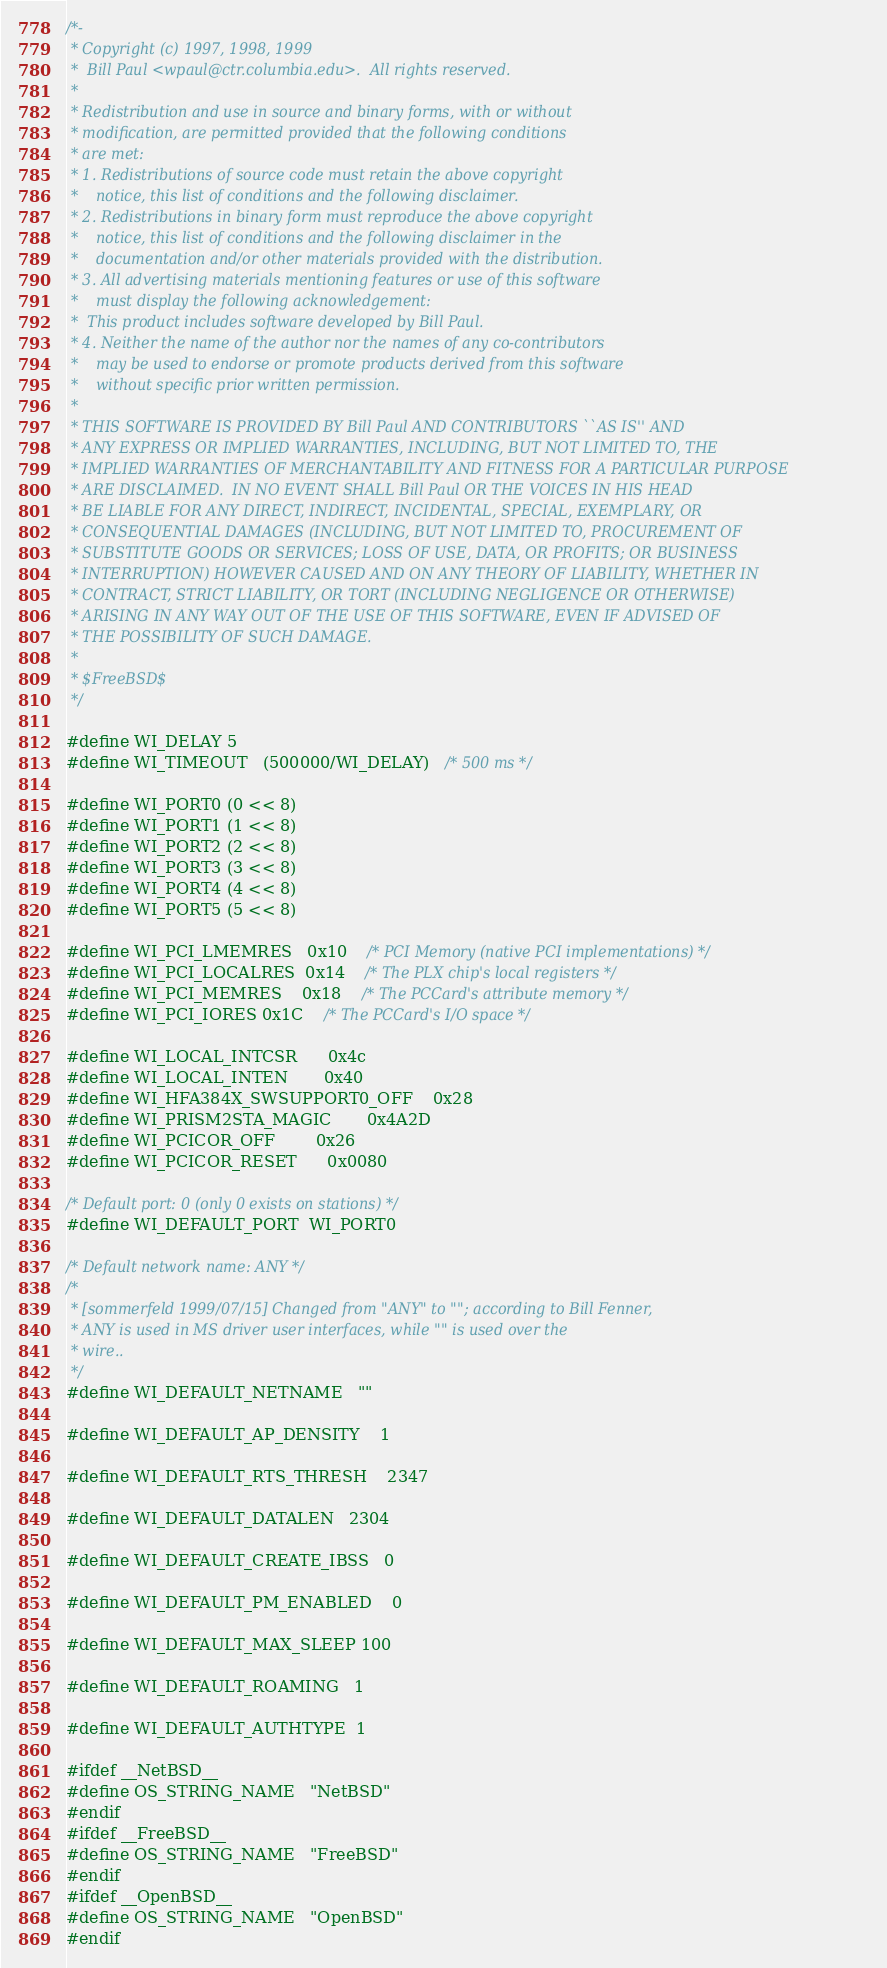Convert code to text. <code><loc_0><loc_0><loc_500><loc_500><_C_>/*-
 * Copyright (c) 1997, 1998, 1999
 *	Bill Paul <wpaul@ctr.columbia.edu>.  All rights reserved.
 *
 * Redistribution and use in source and binary forms, with or without
 * modification, are permitted provided that the following conditions
 * are met:
 * 1. Redistributions of source code must retain the above copyright
 *    notice, this list of conditions and the following disclaimer.
 * 2. Redistributions in binary form must reproduce the above copyright
 *    notice, this list of conditions and the following disclaimer in the
 *    documentation and/or other materials provided with the distribution.
 * 3. All advertising materials mentioning features or use of this software
 *    must display the following acknowledgement:
 *	This product includes software developed by Bill Paul.
 * 4. Neither the name of the author nor the names of any co-contributors
 *    may be used to endorse or promote products derived from this software
 *    without specific prior written permission.
 *
 * THIS SOFTWARE IS PROVIDED BY Bill Paul AND CONTRIBUTORS ``AS IS'' AND
 * ANY EXPRESS OR IMPLIED WARRANTIES, INCLUDING, BUT NOT LIMITED TO, THE
 * IMPLIED WARRANTIES OF MERCHANTABILITY AND FITNESS FOR A PARTICULAR PURPOSE
 * ARE DISCLAIMED.  IN NO EVENT SHALL Bill Paul OR THE VOICES IN HIS HEAD
 * BE LIABLE FOR ANY DIRECT, INDIRECT, INCIDENTAL, SPECIAL, EXEMPLARY, OR
 * CONSEQUENTIAL DAMAGES (INCLUDING, BUT NOT LIMITED TO, PROCUREMENT OF
 * SUBSTITUTE GOODS OR SERVICES; LOSS OF USE, DATA, OR PROFITS; OR BUSINESS
 * INTERRUPTION) HOWEVER CAUSED AND ON ANY THEORY OF LIABILITY, WHETHER IN
 * CONTRACT, STRICT LIABILITY, OR TORT (INCLUDING NEGLIGENCE OR OTHERWISE)
 * ARISING IN ANY WAY OUT OF THE USE OF THIS SOFTWARE, EVEN IF ADVISED OF
 * THE POSSIBILITY OF SUCH DAMAGE.
 *
 * $FreeBSD$
 */

#define WI_DELAY	5
#define WI_TIMEOUT	(500000/WI_DELAY)	/* 500 ms */

#define WI_PORT0	(0 << 8)
#define WI_PORT1	(1 << 8)
#define WI_PORT2	(2 << 8)
#define WI_PORT3	(3 << 8)
#define WI_PORT4	(4 << 8)
#define WI_PORT5	(5 << 8)

#define WI_PCI_LMEMRES	0x10	/* PCI Memory (native PCI implementations) */
#define WI_PCI_LOCALRES	0x14	/* The PLX chip's local registers */
#define WI_PCI_MEMRES	0x18	/* The PCCard's attribute memory */
#define WI_PCI_IORES	0x1C	/* The PCCard's I/O space */

#define WI_LOCAL_INTCSR		0x4c
#define WI_LOCAL_INTEN		0x40
#define WI_HFA384X_SWSUPPORT0_OFF	0x28
#define WI_PRISM2STA_MAGIC		0x4A2D
#define WI_PCICOR_OFF		0x26
#define WI_PCICOR_RESET		0x0080

/* Default port: 0 (only 0 exists on stations) */
#define WI_DEFAULT_PORT	WI_PORT0

/* Default network name: ANY */
/*
 * [sommerfeld 1999/07/15] Changed from "ANY" to ""; according to Bill Fenner,
 * ANY is used in MS driver user interfaces, while "" is used over the
 * wire..
 */
#define WI_DEFAULT_NETNAME	""

#define WI_DEFAULT_AP_DENSITY	1

#define WI_DEFAULT_RTS_THRESH	2347

#define WI_DEFAULT_DATALEN	2304

#define WI_DEFAULT_CREATE_IBSS	0

#define WI_DEFAULT_PM_ENABLED	0

#define WI_DEFAULT_MAX_SLEEP	100

#define WI_DEFAULT_ROAMING	1

#define WI_DEFAULT_AUTHTYPE	1

#ifdef __NetBSD__
#define OS_STRING_NAME	"NetBSD"
#endif
#ifdef __FreeBSD__
#define OS_STRING_NAME	"FreeBSD"
#endif
#ifdef __OpenBSD__
#define OS_STRING_NAME	"OpenBSD"
#endif
</code> 